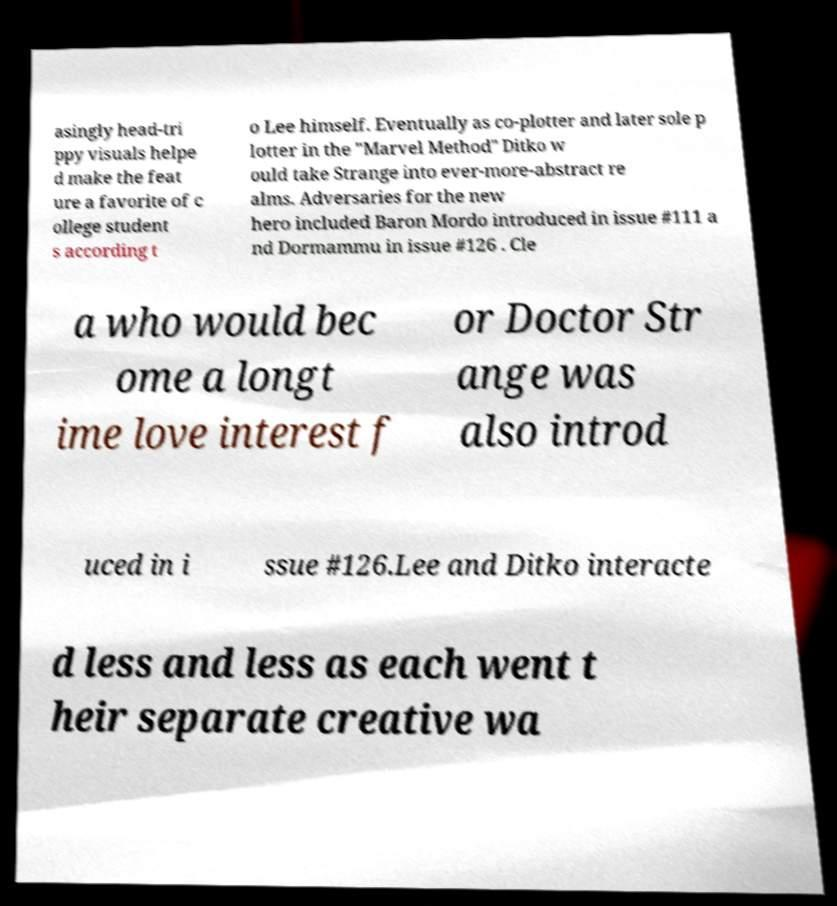Could you assist in decoding the text presented in this image and type it out clearly? asingly head-tri ppy visuals helpe d make the feat ure a favorite of c ollege student s according t o Lee himself. Eventually as co-plotter and later sole p lotter in the "Marvel Method" Ditko w ould take Strange into ever-more-abstract re alms. Adversaries for the new hero included Baron Mordo introduced in issue #111 a nd Dormammu in issue #126 . Cle a who would bec ome a longt ime love interest f or Doctor Str ange was also introd uced in i ssue #126.Lee and Ditko interacte d less and less as each went t heir separate creative wa 